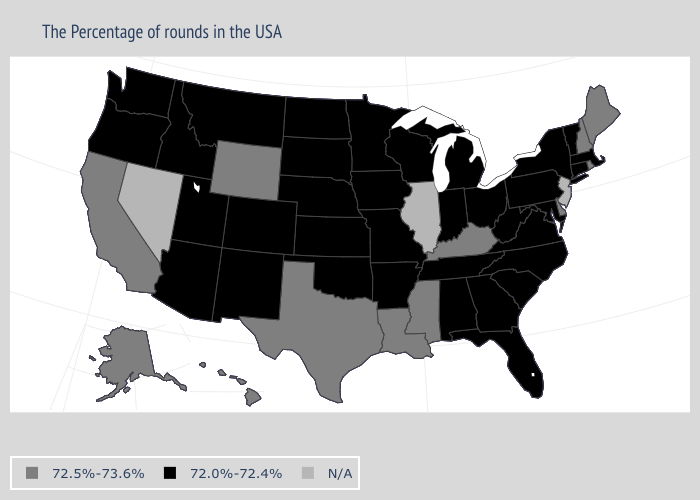What is the value of Maryland?
Write a very short answer. 72.0%-72.4%. Name the states that have a value in the range 72.5%-73.6%?
Answer briefly. Maine, Rhode Island, New Hampshire, Delaware, Kentucky, Mississippi, Louisiana, Texas, Wyoming, California, Alaska, Hawaii. Among the states that border Maine , which have the highest value?
Quick response, please. New Hampshire. What is the highest value in the USA?
Keep it brief. 72.5%-73.6%. Name the states that have a value in the range N/A?
Quick response, please. New Jersey, Illinois, Nevada. How many symbols are there in the legend?
Be succinct. 3. What is the lowest value in the South?
Be succinct. 72.0%-72.4%. Among the states that border California , which have the highest value?
Answer briefly. Arizona, Oregon. Does Maine have the lowest value in the USA?
Quick response, please. No. What is the value of Virginia?
Answer briefly. 72.0%-72.4%. What is the value of Mississippi?
Be succinct. 72.5%-73.6%. What is the highest value in states that border New Hampshire?
Keep it brief. 72.5%-73.6%. What is the value of Connecticut?
Concise answer only. 72.0%-72.4%. What is the highest value in states that border Illinois?
Concise answer only. 72.5%-73.6%. What is the value of Washington?
Concise answer only. 72.0%-72.4%. 